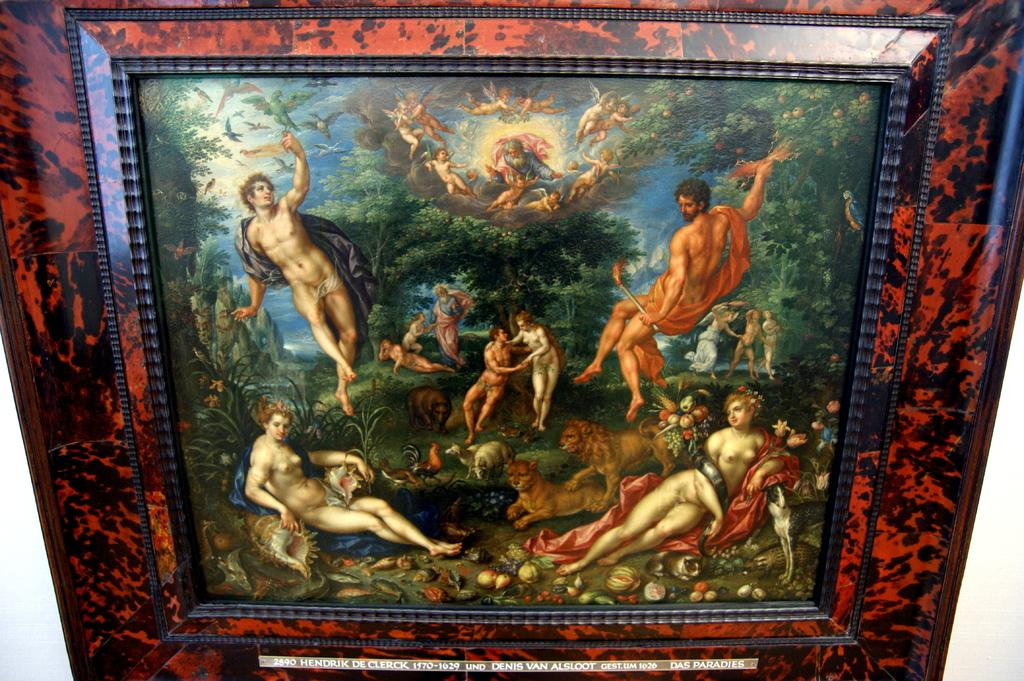Provide a one-sentence caption for the provided image. Hendrik De Clerck 1570-1629 was the artist of the naked people painting. 